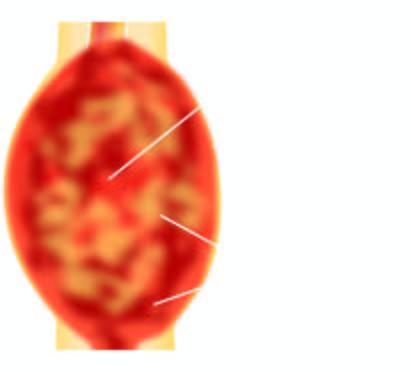s the tumour largely extending into soft tissues including the skeletal muscle?
Answer the question using a single word or phrase. Yes 